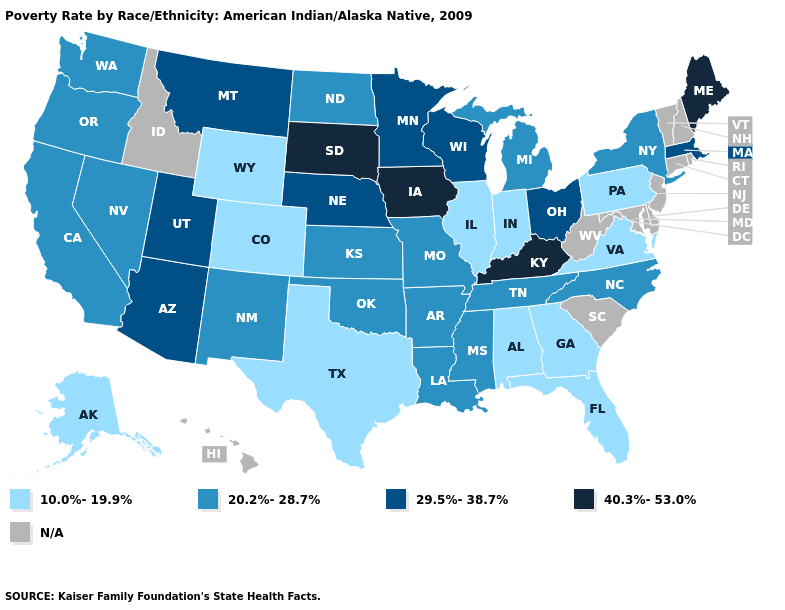Does the first symbol in the legend represent the smallest category?
Be succinct. Yes. Does Colorado have the lowest value in the USA?
Quick response, please. Yes. What is the value of Ohio?
Concise answer only. 29.5%-38.7%. What is the value of Alabama?
Short answer required. 10.0%-19.9%. What is the value of Kentucky?
Short answer required. 40.3%-53.0%. Does New York have the lowest value in the USA?
Be succinct. No. What is the value of Wyoming?
Write a very short answer. 10.0%-19.9%. What is the lowest value in states that border Virginia?
Short answer required. 20.2%-28.7%. Does Arizona have the highest value in the West?
Keep it brief. Yes. What is the value of Kentucky?
Quick response, please. 40.3%-53.0%. What is the value of South Dakota?
Quick response, please. 40.3%-53.0%. Does the map have missing data?
Answer briefly. Yes. Is the legend a continuous bar?
Keep it brief. No. Does the first symbol in the legend represent the smallest category?
Keep it brief. Yes. 